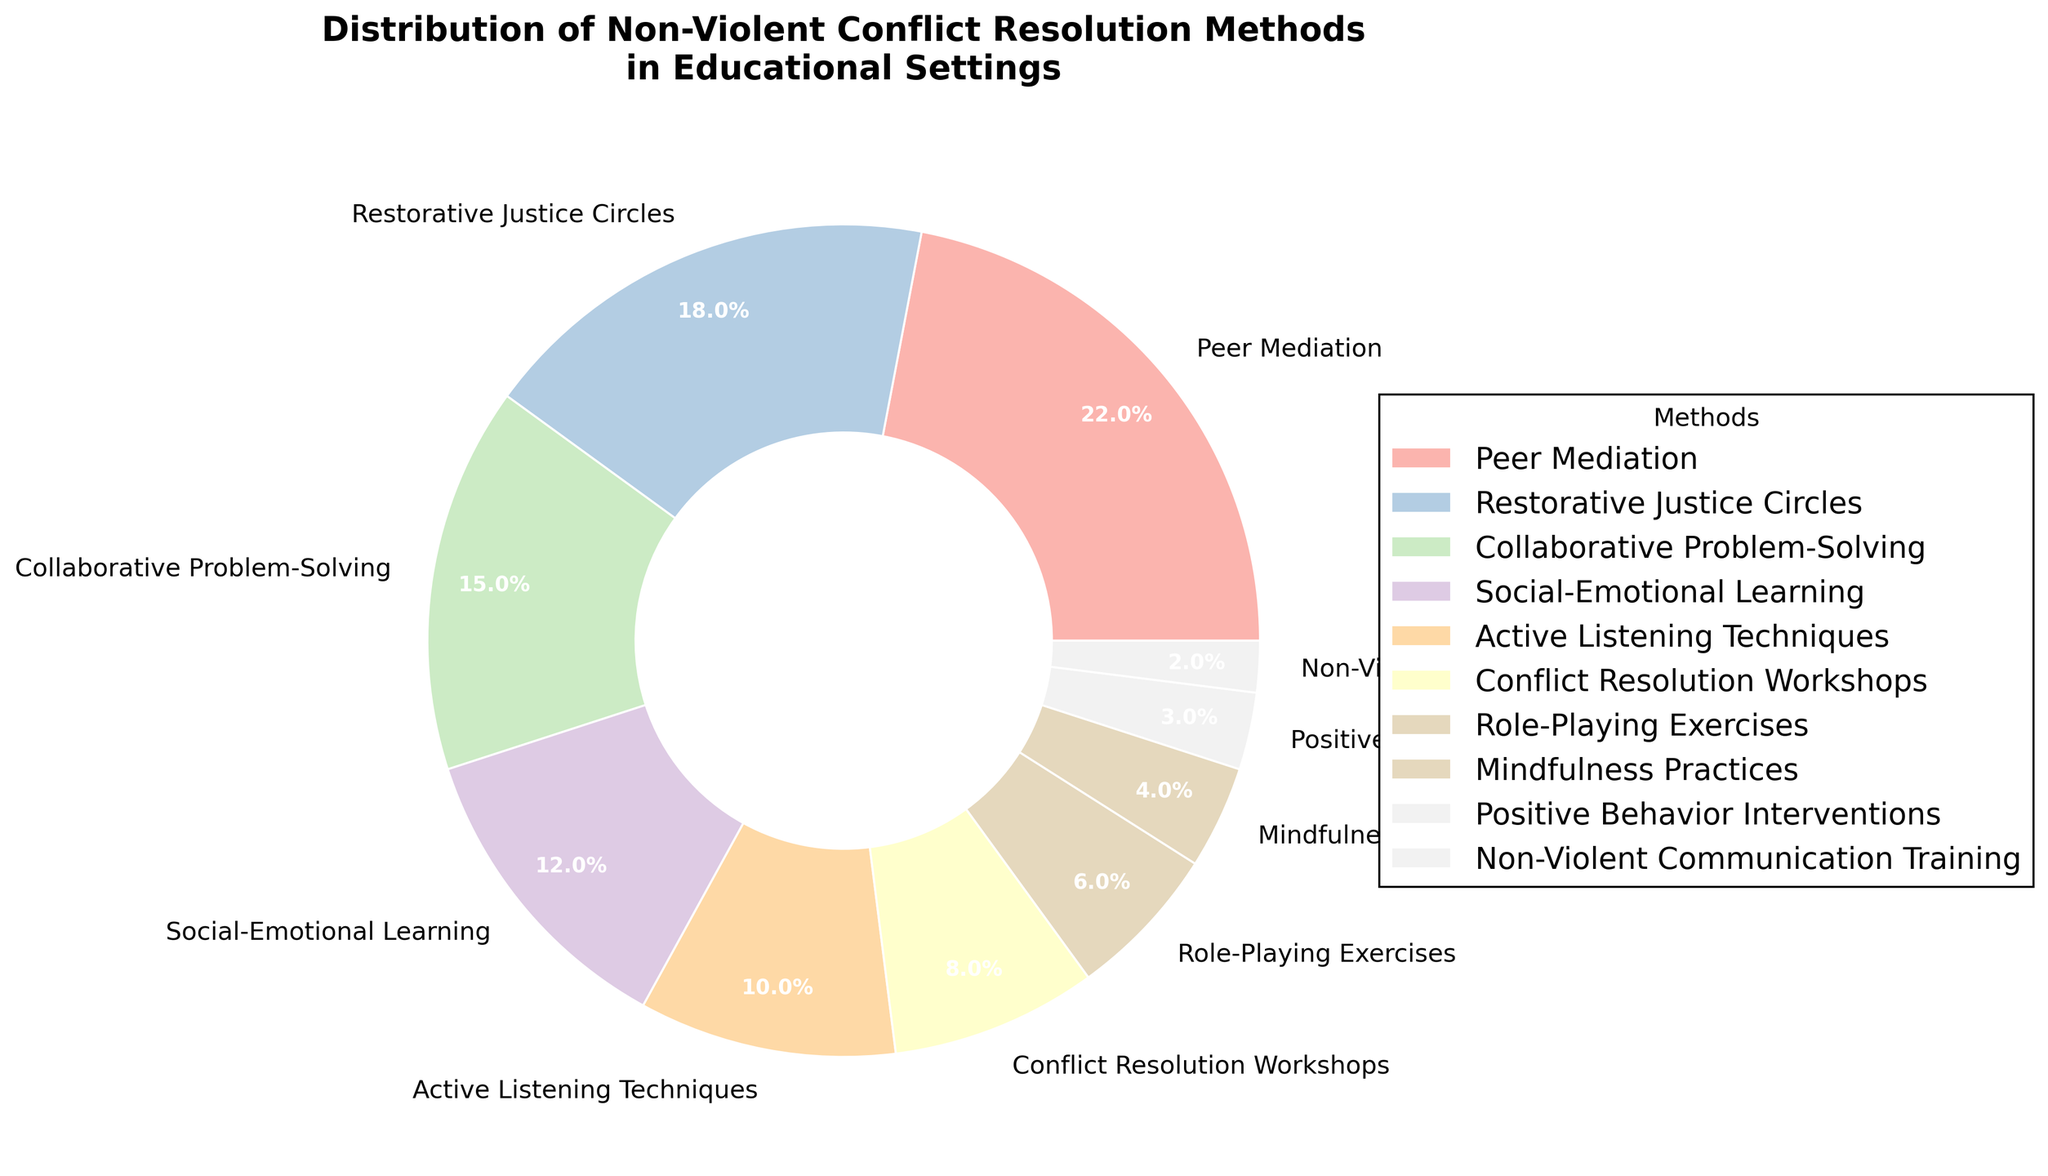Which method has the smallest percentage allocation? Looking at the pie chart, we can see that the smallest slice of the pie corresponds to Non-Violent Communication Training, which is labeled as 2%.
Answer: Non-Violent Communication Training What is the combined percentage of Peer Mediation and Restorative Justice Circles? To find the combined percentage, add the percentage values for Peer Mediation (22%) and Restorative Justice Circles (18%). That sums up to 22 + 18 = 40%.
Answer: 40% Which method uses a lighter color and is labeled with 4%? By referring to the visual properties of the pie chart, we can identify that the lighter color corresponding to 4% is labeled as Mindfulness Practices.
Answer: Mindfulness Practices Does Active Listening Techniques have a higher percentage than Conflict Resolution Workshops? Comparing the two percentages, Active Listening Techniques is 10% while Conflict Resolution Workshops is 8%. 10% is indeed higher than 8%.
Answer: Yes Is the percentage allocation for Role-Playing Exercises more than half of that for Collaborative Problem-Solving? Half of the percentage for Collaborative Problem-Solving (15%) is 15 / 2 = 7.5%. Role-Playing Exercises is 6%, which is less than 7.5%.
Answer: No What is the percentage difference between Social-Emotional Learning and Positive Behavior Interventions? Subtract the percentage of Positive Behavior Interventions (3%) from Social-Emotional Learning (12%). The calculation is 12 - 3 = 9%.
Answer: 9% How many methods have a percentage of 10% or higher? By examining the chart, the methods with 10% or higher are Peer Mediation (22%), Restorative Justice Circles (18%), Collaborative Problem-Solving (15%), Social-Emotional Learning (12%), and Active Listening Techniques (10%). There are 5 such methods.
Answer: 5 Which segment of the chart is visually the largest, and what is its percentage allocation? The visually largest segment of the pie chart corresponds to Peer Mediation, which has a percentage allocation of 22%.
Answer: Peer Mediation, 22% Calculate the total percentage of methods with less than 10% allocation. Adding up the percentages of methods with less than 10%: Conflict Resolution Workshops (8%), Role-Playing Exercises (6%), Mindfulness Practices (4%), Positive Behavior Interventions (3%), Non-Violent Communication Training (2%). The sum is 8 + 6 + 4 + 3 + 2 = 23%.
Answer: 23% What's the percentage allocation for the method using the darkest color in the pie chart? The darkest color visually corresponds to Non-Violent Communication Training, which has an allocation percentage of 2%.
Answer: 2% 